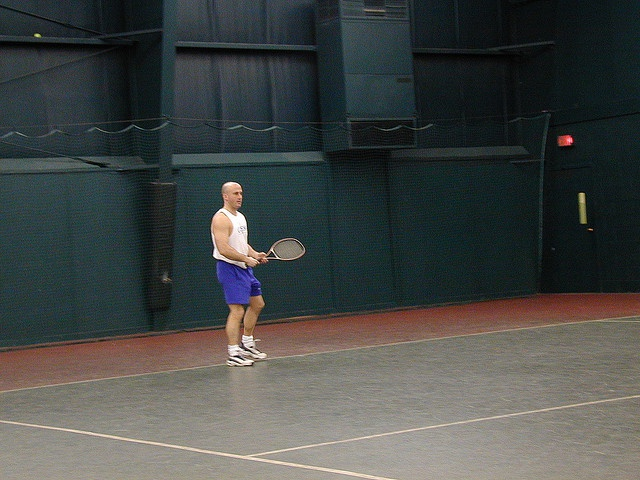Describe the objects in this image and their specific colors. I can see people in black, lightgray, gray, and tan tones, tennis racket in black and gray tones, and sports ball in black, khaki, darkgreen, and olive tones in this image. 